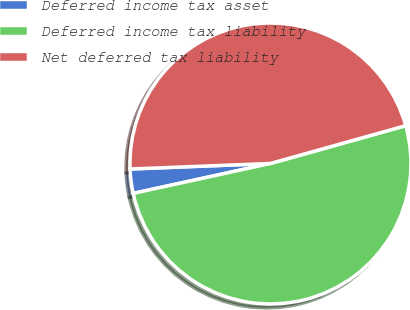Convert chart to OTSL. <chart><loc_0><loc_0><loc_500><loc_500><pie_chart><fcel>Deferred income tax asset<fcel>Deferred income tax liability<fcel>Net deferred tax liability<nl><fcel>2.79%<fcel>50.92%<fcel>46.29%<nl></chart> 